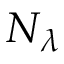Convert formula to latex. <formula><loc_0><loc_0><loc_500><loc_500>N _ { \lambda }</formula> 